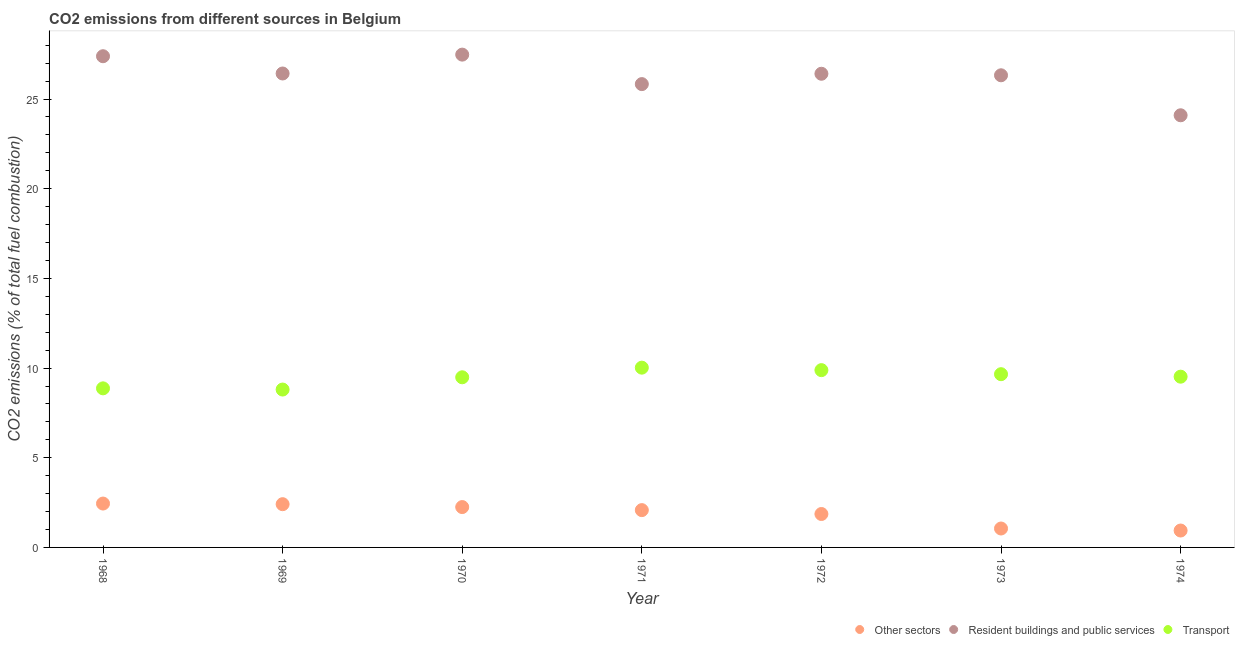How many different coloured dotlines are there?
Ensure brevity in your answer.  3. What is the percentage of co2 emissions from transport in 1973?
Give a very brief answer. 9.66. Across all years, what is the maximum percentage of co2 emissions from transport?
Your answer should be compact. 10.02. Across all years, what is the minimum percentage of co2 emissions from resident buildings and public services?
Give a very brief answer. 24.09. In which year was the percentage of co2 emissions from other sectors minimum?
Offer a very short reply. 1974. What is the total percentage of co2 emissions from resident buildings and public services in the graph?
Make the answer very short. 183.95. What is the difference between the percentage of co2 emissions from other sectors in 1968 and that in 1971?
Provide a succinct answer. 0.37. What is the difference between the percentage of co2 emissions from other sectors in 1972 and the percentage of co2 emissions from resident buildings and public services in 1971?
Make the answer very short. -23.97. What is the average percentage of co2 emissions from transport per year?
Make the answer very short. 9.46. In the year 1968, what is the difference between the percentage of co2 emissions from transport and percentage of co2 emissions from resident buildings and public services?
Provide a succinct answer. -18.52. What is the ratio of the percentage of co2 emissions from transport in 1971 to that in 1973?
Ensure brevity in your answer.  1.04. Is the percentage of co2 emissions from transport in 1968 less than that in 1970?
Provide a short and direct response. Yes. What is the difference between the highest and the second highest percentage of co2 emissions from other sectors?
Provide a succinct answer. 0.04. What is the difference between the highest and the lowest percentage of co2 emissions from resident buildings and public services?
Your answer should be very brief. 3.38. Is it the case that in every year, the sum of the percentage of co2 emissions from other sectors and percentage of co2 emissions from resident buildings and public services is greater than the percentage of co2 emissions from transport?
Offer a terse response. Yes. Does the percentage of co2 emissions from resident buildings and public services monotonically increase over the years?
Offer a very short reply. No. Is the percentage of co2 emissions from resident buildings and public services strictly greater than the percentage of co2 emissions from transport over the years?
Provide a short and direct response. Yes. Is the percentage of co2 emissions from transport strictly less than the percentage of co2 emissions from other sectors over the years?
Make the answer very short. No. How many dotlines are there?
Give a very brief answer. 3. Are the values on the major ticks of Y-axis written in scientific E-notation?
Provide a succinct answer. No. Does the graph contain any zero values?
Give a very brief answer. No. Does the graph contain grids?
Provide a succinct answer. No. Where does the legend appear in the graph?
Your answer should be very brief. Bottom right. What is the title of the graph?
Ensure brevity in your answer.  CO2 emissions from different sources in Belgium. What is the label or title of the X-axis?
Your answer should be very brief. Year. What is the label or title of the Y-axis?
Keep it short and to the point. CO2 emissions (% of total fuel combustion). What is the CO2 emissions (% of total fuel combustion) in Other sectors in 1968?
Offer a very short reply. 2.45. What is the CO2 emissions (% of total fuel combustion) of Resident buildings and public services in 1968?
Keep it short and to the point. 27.39. What is the CO2 emissions (% of total fuel combustion) of Transport in 1968?
Ensure brevity in your answer.  8.87. What is the CO2 emissions (% of total fuel combustion) in Other sectors in 1969?
Make the answer very short. 2.41. What is the CO2 emissions (% of total fuel combustion) of Resident buildings and public services in 1969?
Your response must be concise. 26.42. What is the CO2 emissions (% of total fuel combustion) of Transport in 1969?
Offer a very short reply. 8.8. What is the CO2 emissions (% of total fuel combustion) in Other sectors in 1970?
Provide a succinct answer. 2.25. What is the CO2 emissions (% of total fuel combustion) of Resident buildings and public services in 1970?
Offer a very short reply. 27.48. What is the CO2 emissions (% of total fuel combustion) of Transport in 1970?
Make the answer very short. 9.49. What is the CO2 emissions (% of total fuel combustion) in Other sectors in 1971?
Your response must be concise. 2.08. What is the CO2 emissions (% of total fuel combustion) in Resident buildings and public services in 1971?
Provide a succinct answer. 25.83. What is the CO2 emissions (% of total fuel combustion) in Transport in 1971?
Your response must be concise. 10.02. What is the CO2 emissions (% of total fuel combustion) in Other sectors in 1972?
Your answer should be very brief. 1.86. What is the CO2 emissions (% of total fuel combustion) in Resident buildings and public services in 1972?
Your response must be concise. 26.41. What is the CO2 emissions (% of total fuel combustion) of Transport in 1972?
Provide a short and direct response. 9.88. What is the CO2 emissions (% of total fuel combustion) of Other sectors in 1973?
Offer a very short reply. 1.05. What is the CO2 emissions (% of total fuel combustion) of Resident buildings and public services in 1973?
Offer a very short reply. 26.32. What is the CO2 emissions (% of total fuel combustion) of Transport in 1973?
Offer a terse response. 9.66. What is the CO2 emissions (% of total fuel combustion) of Other sectors in 1974?
Provide a short and direct response. 0.94. What is the CO2 emissions (% of total fuel combustion) of Resident buildings and public services in 1974?
Offer a terse response. 24.09. What is the CO2 emissions (% of total fuel combustion) of Transport in 1974?
Your answer should be very brief. 9.52. Across all years, what is the maximum CO2 emissions (% of total fuel combustion) in Other sectors?
Your response must be concise. 2.45. Across all years, what is the maximum CO2 emissions (% of total fuel combustion) of Resident buildings and public services?
Your answer should be very brief. 27.48. Across all years, what is the maximum CO2 emissions (% of total fuel combustion) of Transport?
Provide a succinct answer. 10.02. Across all years, what is the minimum CO2 emissions (% of total fuel combustion) of Other sectors?
Provide a succinct answer. 0.94. Across all years, what is the minimum CO2 emissions (% of total fuel combustion) in Resident buildings and public services?
Your response must be concise. 24.09. Across all years, what is the minimum CO2 emissions (% of total fuel combustion) of Transport?
Provide a succinct answer. 8.8. What is the total CO2 emissions (% of total fuel combustion) in Other sectors in the graph?
Provide a succinct answer. 13.05. What is the total CO2 emissions (% of total fuel combustion) of Resident buildings and public services in the graph?
Your answer should be compact. 183.95. What is the total CO2 emissions (% of total fuel combustion) in Transport in the graph?
Make the answer very short. 66.24. What is the difference between the CO2 emissions (% of total fuel combustion) in Other sectors in 1968 and that in 1969?
Keep it short and to the point. 0.04. What is the difference between the CO2 emissions (% of total fuel combustion) in Resident buildings and public services in 1968 and that in 1969?
Give a very brief answer. 0.96. What is the difference between the CO2 emissions (% of total fuel combustion) of Transport in 1968 and that in 1969?
Your answer should be compact. 0.07. What is the difference between the CO2 emissions (% of total fuel combustion) of Other sectors in 1968 and that in 1970?
Keep it short and to the point. 0.2. What is the difference between the CO2 emissions (% of total fuel combustion) of Resident buildings and public services in 1968 and that in 1970?
Provide a succinct answer. -0.09. What is the difference between the CO2 emissions (% of total fuel combustion) of Transport in 1968 and that in 1970?
Offer a very short reply. -0.62. What is the difference between the CO2 emissions (% of total fuel combustion) of Other sectors in 1968 and that in 1971?
Provide a short and direct response. 0.37. What is the difference between the CO2 emissions (% of total fuel combustion) of Resident buildings and public services in 1968 and that in 1971?
Your answer should be very brief. 1.55. What is the difference between the CO2 emissions (% of total fuel combustion) of Transport in 1968 and that in 1971?
Offer a very short reply. -1.15. What is the difference between the CO2 emissions (% of total fuel combustion) in Other sectors in 1968 and that in 1972?
Keep it short and to the point. 0.58. What is the difference between the CO2 emissions (% of total fuel combustion) of Resident buildings and public services in 1968 and that in 1972?
Offer a terse response. 0.98. What is the difference between the CO2 emissions (% of total fuel combustion) of Transport in 1968 and that in 1972?
Keep it short and to the point. -1.02. What is the difference between the CO2 emissions (% of total fuel combustion) in Other sectors in 1968 and that in 1973?
Offer a very short reply. 1.39. What is the difference between the CO2 emissions (% of total fuel combustion) of Resident buildings and public services in 1968 and that in 1973?
Your response must be concise. 1.06. What is the difference between the CO2 emissions (% of total fuel combustion) of Transport in 1968 and that in 1973?
Your answer should be very brief. -0.79. What is the difference between the CO2 emissions (% of total fuel combustion) of Other sectors in 1968 and that in 1974?
Give a very brief answer. 1.5. What is the difference between the CO2 emissions (% of total fuel combustion) in Resident buildings and public services in 1968 and that in 1974?
Give a very brief answer. 3.29. What is the difference between the CO2 emissions (% of total fuel combustion) in Transport in 1968 and that in 1974?
Keep it short and to the point. -0.65. What is the difference between the CO2 emissions (% of total fuel combustion) of Other sectors in 1969 and that in 1970?
Give a very brief answer. 0.16. What is the difference between the CO2 emissions (% of total fuel combustion) in Resident buildings and public services in 1969 and that in 1970?
Keep it short and to the point. -1.05. What is the difference between the CO2 emissions (% of total fuel combustion) of Transport in 1969 and that in 1970?
Your answer should be very brief. -0.68. What is the difference between the CO2 emissions (% of total fuel combustion) in Other sectors in 1969 and that in 1971?
Provide a short and direct response. 0.33. What is the difference between the CO2 emissions (% of total fuel combustion) in Resident buildings and public services in 1969 and that in 1971?
Your answer should be compact. 0.59. What is the difference between the CO2 emissions (% of total fuel combustion) of Transport in 1969 and that in 1971?
Offer a terse response. -1.22. What is the difference between the CO2 emissions (% of total fuel combustion) in Other sectors in 1969 and that in 1972?
Ensure brevity in your answer.  0.55. What is the difference between the CO2 emissions (% of total fuel combustion) in Resident buildings and public services in 1969 and that in 1972?
Make the answer very short. 0.02. What is the difference between the CO2 emissions (% of total fuel combustion) of Transport in 1969 and that in 1972?
Your response must be concise. -1.08. What is the difference between the CO2 emissions (% of total fuel combustion) of Other sectors in 1969 and that in 1973?
Your answer should be very brief. 1.36. What is the difference between the CO2 emissions (% of total fuel combustion) in Resident buildings and public services in 1969 and that in 1973?
Your response must be concise. 0.1. What is the difference between the CO2 emissions (% of total fuel combustion) of Transport in 1969 and that in 1973?
Make the answer very short. -0.86. What is the difference between the CO2 emissions (% of total fuel combustion) of Other sectors in 1969 and that in 1974?
Provide a short and direct response. 1.47. What is the difference between the CO2 emissions (% of total fuel combustion) in Resident buildings and public services in 1969 and that in 1974?
Your answer should be compact. 2.33. What is the difference between the CO2 emissions (% of total fuel combustion) in Transport in 1969 and that in 1974?
Your answer should be compact. -0.72. What is the difference between the CO2 emissions (% of total fuel combustion) in Other sectors in 1970 and that in 1971?
Offer a terse response. 0.17. What is the difference between the CO2 emissions (% of total fuel combustion) of Resident buildings and public services in 1970 and that in 1971?
Make the answer very short. 1.64. What is the difference between the CO2 emissions (% of total fuel combustion) in Transport in 1970 and that in 1971?
Offer a very short reply. -0.54. What is the difference between the CO2 emissions (% of total fuel combustion) in Other sectors in 1970 and that in 1972?
Provide a short and direct response. 0.39. What is the difference between the CO2 emissions (% of total fuel combustion) of Resident buildings and public services in 1970 and that in 1972?
Make the answer very short. 1.07. What is the difference between the CO2 emissions (% of total fuel combustion) of Transport in 1970 and that in 1972?
Make the answer very short. -0.4. What is the difference between the CO2 emissions (% of total fuel combustion) of Other sectors in 1970 and that in 1973?
Your response must be concise. 1.2. What is the difference between the CO2 emissions (% of total fuel combustion) in Resident buildings and public services in 1970 and that in 1973?
Provide a short and direct response. 1.15. What is the difference between the CO2 emissions (% of total fuel combustion) in Transport in 1970 and that in 1973?
Your answer should be very brief. -0.17. What is the difference between the CO2 emissions (% of total fuel combustion) in Other sectors in 1970 and that in 1974?
Keep it short and to the point. 1.31. What is the difference between the CO2 emissions (% of total fuel combustion) of Resident buildings and public services in 1970 and that in 1974?
Keep it short and to the point. 3.38. What is the difference between the CO2 emissions (% of total fuel combustion) in Transport in 1970 and that in 1974?
Make the answer very short. -0.03. What is the difference between the CO2 emissions (% of total fuel combustion) of Other sectors in 1971 and that in 1972?
Offer a terse response. 0.22. What is the difference between the CO2 emissions (% of total fuel combustion) in Resident buildings and public services in 1971 and that in 1972?
Give a very brief answer. -0.58. What is the difference between the CO2 emissions (% of total fuel combustion) in Transport in 1971 and that in 1972?
Offer a very short reply. 0.14. What is the difference between the CO2 emissions (% of total fuel combustion) in Other sectors in 1971 and that in 1973?
Your response must be concise. 1.03. What is the difference between the CO2 emissions (% of total fuel combustion) in Resident buildings and public services in 1971 and that in 1973?
Provide a short and direct response. -0.49. What is the difference between the CO2 emissions (% of total fuel combustion) in Transport in 1971 and that in 1973?
Your answer should be compact. 0.36. What is the difference between the CO2 emissions (% of total fuel combustion) of Other sectors in 1971 and that in 1974?
Provide a succinct answer. 1.14. What is the difference between the CO2 emissions (% of total fuel combustion) in Resident buildings and public services in 1971 and that in 1974?
Make the answer very short. 1.74. What is the difference between the CO2 emissions (% of total fuel combustion) in Transport in 1971 and that in 1974?
Ensure brevity in your answer.  0.5. What is the difference between the CO2 emissions (% of total fuel combustion) in Other sectors in 1972 and that in 1973?
Your answer should be very brief. 0.81. What is the difference between the CO2 emissions (% of total fuel combustion) of Resident buildings and public services in 1972 and that in 1973?
Ensure brevity in your answer.  0.09. What is the difference between the CO2 emissions (% of total fuel combustion) of Transport in 1972 and that in 1973?
Your response must be concise. 0.23. What is the difference between the CO2 emissions (% of total fuel combustion) of Other sectors in 1972 and that in 1974?
Offer a terse response. 0.92. What is the difference between the CO2 emissions (% of total fuel combustion) of Resident buildings and public services in 1972 and that in 1974?
Ensure brevity in your answer.  2.31. What is the difference between the CO2 emissions (% of total fuel combustion) of Transport in 1972 and that in 1974?
Your response must be concise. 0.36. What is the difference between the CO2 emissions (% of total fuel combustion) in Other sectors in 1973 and that in 1974?
Give a very brief answer. 0.11. What is the difference between the CO2 emissions (% of total fuel combustion) of Resident buildings and public services in 1973 and that in 1974?
Your response must be concise. 2.23. What is the difference between the CO2 emissions (% of total fuel combustion) of Transport in 1973 and that in 1974?
Ensure brevity in your answer.  0.14. What is the difference between the CO2 emissions (% of total fuel combustion) of Other sectors in 1968 and the CO2 emissions (% of total fuel combustion) of Resident buildings and public services in 1969?
Give a very brief answer. -23.98. What is the difference between the CO2 emissions (% of total fuel combustion) of Other sectors in 1968 and the CO2 emissions (% of total fuel combustion) of Transport in 1969?
Offer a very short reply. -6.36. What is the difference between the CO2 emissions (% of total fuel combustion) in Resident buildings and public services in 1968 and the CO2 emissions (% of total fuel combustion) in Transport in 1969?
Keep it short and to the point. 18.58. What is the difference between the CO2 emissions (% of total fuel combustion) in Other sectors in 1968 and the CO2 emissions (% of total fuel combustion) in Resident buildings and public services in 1970?
Keep it short and to the point. -25.03. What is the difference between the CO2 emissions (% of total fuel combustion) in Other sectors in 1968 and the CO2 emissions (% of total fuel combustion) in Transport in 1970?
Keep it short and to the point. -7.04. What is the difference between the CO2 emissions (% of total fuel combustion) in Resident buildings and public services in 1968 and the CO2 emissions (% of total fuel combustion) in Transport in 1970?
Your response must be concise. 17.9. What is the difference between the CO2 emissions (% of total fuel combustion) of Other sectors in 1968 and the CO2 emissions (% of total fuel combustion) of Resident buildings and public services in 1971?
Give a very brief answer. -23.39. What is the difference between the CO2 emissions (% of total fuel combustion) in Other sectors in 1968 and the CO2 emissions (% of total fuel combustion) in Transport in 1971?
Your response must be concise. -7.58. What is the difference between the CO2 emissions (% of total fuel combustion) of Resident buildings and public services in 1968 and the CO2 emissions (% of total fuel combustion) of Transport in 1971?
Your answer should be compact. 17.36. What is the difference between the CO2 emissions (% of total fuel combustion) in Other sectors in 1968 and the CO2 emissions (% of total fuel combustion) in Resident buildings and public services in 1972?
Your answer should be compact. -23.96. What is the difference between the CO2 emissions (% of total fuel combustion) of Other sectors in 1968 and the CO2 emissions (% of total fuel combustion) of Transport in 1972?
Give a very brief answer. -7.44. What is the difference between the CO2 emissions (% of total fuel combustion) of Resident buildings and public services in 1968 and the CO2 emissions (% of total fuel combustion) of Transport in 1972?
Make the answer very short. 17.5. What is the difference between the CO2 emissions (% of total fuel combustion) in Other sectors in 1968 and the CO2 emissions (% of total fuel combustion) in Resident buildings and public services in 1973?
Provide a succinct answer. -23.88. What is the difference between the CO2 emissions (% of total fuel combustion) of Other sectors in 1968 and the CO2 emissions (% of total fuel combustion) of Transport in 1973?
Your answer should be very brief. -7.21. What is the difference between the CO2 emissions (% of total fuel combustion) of Resident buildings and public services in 1968 and the CO2 emissions (% of total fuel combustion) of Transport in 1973?
Your answer should be compact. 17.73. What is the difference between the CO2 emissions (% of total fuel combustion) of Other sectors in 1968 and the CO2 emissions (% of total fuel combustion) of Resident buildings and public services in 1974?
Your answer should be compact. -21.65. What is the difference between the CO2 emissions (% of total fuel combustion) of Other sectors in 1968 and the CO2 emissions (% of total fuel combustion) of Transport in 1974?
Keep it short and to the point. -7.07. What is the difference between the CO2 emissions (% of total fuel combustion) of Resident buildings and public services in 1968 and the CO2 emissions (% of total fuel combustion) of Transport in 1974?
Offer a terse response. 17.87. What is the difference between the CO2 emissions (% of total fuel combustion) in Other sectors in 1969 and the CO2 emissions (% of total fuel combustion) in Resident buildings and public services in 1970?
Provide a short and direct response. -25.07. What is the difference between the CO2 emissions (% of total fuel combustion) in Other sectors in 1969 and the CO2 emissions (% of total fuel combustion) in Transport in 1970?
Your answer should be compact. -7.08. What is the difference between the CO2 emissions (% of total fuel combustion) in Resident buildings and public services in 1969 and the CO2 emissions (% of total fuel combustion) in Transport in 1970?
Offer a very short reply. 16.94. What is the difference between the CO2 emissions (% of total fuel combustion) of Other sectors in 1969 and the CO2 emissions (% of total fuel combustion) of Resident buildings and public services in 1971?
Your response must be concise. -23.42. What is the difference between the CO2 emissions (% of total fuel combustion) in Other sectors in 1969 and the CO2 emissions (% of total fuel combustion) in Transport in 1971?
Offer a very short reply. -7.61. What is the difference between the CO2 emissions (% of total fuel combustion) of Resident buildings and public services in 1969 and the CO2 emissions (% of total fuel combustion) of Transport in 1971?
Make the answer very short. 16.4. What is the difference between the CO2 emissions (% of total fuel combustion) in Other sectors in 1969 and the CO2 emissions (% of total fuel combustion) in Resident buildings and public services in 1972?
Provide a short and direct response. -24. What is the difference between the CO2 emissions (% of total fuel combustion) in Other sectors in 1969 and the CO2 emissions (% of total fuel combustion) in Transport in 1972?
Your response must be concise. -7.47. What is the difference between the CO2 emissions (% of total fuel combustion) in Resident buildings and public services in 1969 and the CO2 emissions (% of total fuel combustion) in Transport in 1972?
Offer a terse response. 16.54. What is the difference between the CO2 emissions (% of total fuel combustion) of Other sectors in 1969 and the CO2 emissions (% of total fuel combustion) of Resident buildings and public services in 1973?
Offer a terse response. -23.91. What is the difference between the CO2 emissions (% of total fuel combustion) in Other sectors in 1969 and the CO2 emissions (% of total fuel combustion) in Transport in 1973?
Offer a very short reply. -7.25. What is the difference between the CO2 emissions (% of total fuel combustion) in Resident buildings and public services in 1969 and the CO2 emissions (% of total fuel combustion) in Transport in 1973?
Your answer should be compact. 16.77. What is the difference between the CO2 emissions (% of total fuel combustion) of Other sectors in 1969 and the CO2 emissions (% of total fuel combustion) of Resident buildings and public services in 1974?
Offer a terse response. -21.68. What is the difference between the CO2 emissions (% of total fuel combustion) of Other sectors in 1969 and the CO2 emissions (% of total fuel combustion) of Transport in 1974?
Make the answer very short. -7.11. What is the difference between the CO2 emissions (% of total fuel combustion) in Resident buildings and public services in 1969 and the CO2 emissions (% of total fuel combustion) in Transport in 1974?
Offer a very short reply. 16.9. What is the difference between the CO2 emissions (% of total fuel combustion) of Other sectors in 1970 and the CO2 emissions (% of total fuel combustion) of Resident buildings and public services in 1971?
Provide a succinct answer. -23.58. What is the difference between the CO2 emissions (% of total fuel combustion) in Other sectors in 1970 and the CO2 emissions (% of total fuel combustion) in Transport in 1971?
Your answer should be compact. -7.77. What is the difference between the CO2 emissions (% of total fuel combustion) of Resident buildings and public services in 1970 and the CO2 emissions (% of total fuel combustion) of Transport in 1971?
Provide a short and direct response. 17.45. What is the difference between the CO2 emissions (% of total fuel combustion) of Other sectors in 1970 and the CO2 emissions (% of total fuel combustion) of Resident buildings and public services in 1972?
Provide a succinct answer. -24.16. What is the difference between the CO2 emissions (% of total fuel combustion) in Other sectors in 1970 and the CO2 emissions (% of total fuel combustion) in Transport in 1972?
Give a very brief answer. -7.63. What is the difference between the CO2 emissions (% of total fuel combustion) of Resident buildings and public services in 1970 and the CO2 emissions (% of total fuel combustion) of Transport in 1972?
Provide a succinct answer. 17.59. What is the difference between the CO2 emissions (% of total fuel combustion) of Other sectors in 1970 and the CO2 emissions (% of total fuel combustion) of Resident buildings and public services in 1973?
Your answer should be very brief. -24.07. What is the difference between the CO2 emissions (% of total fuel combustion) in Other sectors in 1970 and the CO2 emissions (% of total fuel combustion) in Transport in 1973?
Provide a succinct answer. -7.41. What is the difference between the CO2 emissions (% of total fuel combustion) in Resident buildings and public services in 1970 and the CO2 emissions (% of total fuel combustion) in Transport in 1973?
Offer a terse response. 17.82. What is the difference between the CO2 emissions (% of total fuel combustion) of Other sectors in 1970 and the CO2 emissions (% of total fuel combustion) of Resident buildings and public services in 1974?
Your response must be concise. -21.84. What is the difference between the CO2 emissions (% of total fuel combustion) in Other sectors in 1970 and the CO2 emissions (% of total fuel combustion) in Transport in 1974?
Your answer should be compact. -7.27. What is the difference between the CO2 emissions (% of total fuel combustion) of Resident buildings and public services in 1970 and the CO2 emissions (% of total fuel combustion) of Transport in 1974?
Your answer should be compact. 17.96. What is the difference between the CO2 emissions (% of total fuel combustion) in Other sectors in 1971 and the CO2 emissions (% of total fuel combustion) in Resident buildings and public services in 1972?
Ensure brevity in your answer.  -24.33. What is the difference between the CO2 emissions (% of total fuel combustion) of Other sectors in 1971 and the CO2 emissions (% of total fuel combustion) of Transport in 1972?
Your answer should be compact. -7.8. What is the difference between the CO2 emissions (% of total fuel combustion) of Resident buildings and public services in 1971 and the CO2 emissions (% of total fuel combustion) of Transport in 1972?
Ensure brevity in your answer.  15.95. What is the difference between the CO2 emissions (% of total fuel combustion) in Other sectors in 1971 and the CO2 emissions (% of total fuel combustion) in Resident buildings and public services in 1973?
Ensure brevity in your answer.  -24.24. What is the difference between the CO2 emissions (% of total fuel combustion) of Other sectors in 1971 and the CO2 emissions (% of total fuel combustion) of Transport in 1973?
Provide a short and direct response. -7.58. What is the difference between the CO2 emissions (% of total fuel combustion) in Resident buildings and public services in 1971 and the CO2 emissions (% of total fuel combustion) in Transport in 1973?
Your response must be concise. 16.17. What is the difference between the CO2 emissions (% of total fuel combustion) in Other sectors in 1971 and the CO2 emissions (% of total fuel combustion) in Resident buildings and public services in 1974?
Ensure brevity in your answer.  -22.01. What is the difference between the CO2 emissions (% of total fuel combustion) in Other sectors in 1971 and the CO2 emissions (% of total fuel combustion) in Transport in 1974?
Give a very brief answer. -7.44. What is the difference between the CO2 emissions (% of total fuel combustion) of Resident buildings and public services in 1971 and the CO2 emissions (% of total fuel combustion) of Transport in 1974?
Make the answer very short. 16.31. What is the difference between the CO2 emissions (% of total fuel combustion) of Other sectors in 1972 and the CO2 emissions (% of total fuel combustion) of Resident buildings and public services in 1973?
Your response must be concise. -24.46. What is the difference between the CO2 emissions (% of total fuel combustion) in Other sectors in 1972 and the CO2 emissions (% of total fuel combustion) in Transport in 1973?
Offer a very short reply. -7.8. What is the difference between the CO2 emissions (% of total fuel combustion) in Resident buildings and public services in 1972 and the CO2 emissions (% of total fuel combustion) in Transport in 1973?
Ensure brevity in your answer.  16.75. What is the difference between the CO2 emissions (% of total fuel combustion) of Other sectors in 1972 and the CO2 emissions (% of total fuel combustion) of Resident buildings and public services in 1974?
Make the answer very short. -22.23. What is the difference between the CO2 emissions (% of total fuel combustion) of Other sectors in 1972 and the CO2 emissions (% of total fuel combustion) of Transport in 1974?
Your response must be concise. -7.66. What is the difference between the CO2 emissions (% of total fuel combustion) of Resident buildings and public services in 1972 and the CO2 emissions (% of total fuel combustion) of Transport in 1974?
Keep it short and to the point. 16.89. What is the difference between the CO2 emissions (% of total fuel combustion) of Other sectors in 1973 and the CO2 emissions (% of total fuel combustion) of Resident buildings and public services in 1974?
Provide a short and direct response. -23.04. What is the difference between the CO2 emissions (% of total fuel combustion) in Other sectors in 1973 and the CO2 emissions (% of total fuel combustion) in Transport in 1974?
Give a very brief answer. -8.46. What is the difference between the CO2 emissions (% of total fuel combustion) in Resident buildings and public services in 1973 and the CO2 emissions (% of total fuel combustion) in Transport in 1974?
Make the answer very short. 16.8. What is the average CO2 emissions (% of total fuel combustion) in Other sectors per year?
Give a very brief answer. 1.86. What is the average CO2 emissions (% of total fuel combustion) in Resident buildings and public services per year?
Offer a terse response. 26.28. What is the average CO2 emissions (% of total fuel combustion) in Transport per year?
Give a very brief answer. 9.46. In the year 1968, what is the difference between the CO2 emissions (% of total fuel combustion) in Other sectors and CO2 emissions (% of total fuel combustion) in Resident buildings and public services?
Give a very brief answer. -24.94. In the year 1968, what is the difference between the CO2 emissions (% of total fuel combustion) in Other sectors and CO2 emissions (% of total fuel combustion) in Transport?
Ensure brevity in your answer.  -6.42. In the year 1968, what is the difference between the CO2 emissions (% of total fuel combustion) of Resident buildings and public services and CO2 emissions (% of total fuel combustion) of Transport?
Your answer should be compact. 18.52. In the year 1969, what is the difference between the CO2 emissions (% of total fuel combustion) in Other sectors and CO2 emissions (% of total fuel combustion) in Resident buildings and public services?
Your answer should be very brief. -24.01. In the year 1969, what is the difference between the CO2 emissions (% of total fuel combustion) of Other sectors and CO2 emissions (% of total fuel combustion) of Transport?
Keep it short and to the point. -6.39. In the year 1969, what is the difference between the CO2 emissions (% of total fuel combustion) in Resident buildings and public services and CO2 emissions (% of total fuel combustion) in Transport?
Your answer should be compact. 17.62. In the year 1970, what is the difference between the CO2 emissions (% of total fuel combustion) in Other sectors and CO2 emissions (% of total fuel combustion) in Resident buildings and public services?
Your answer should be very brief. -25.23. In the year 1970, what is the difference between the CO2 emissions (% of total fuel combustion) in Other sectors and CO2 emissions (% of total fuel combustion) in Transport?
Make the answer very short. -7.24. In the year 1970, what is the difference between the CO2 emissions (% of total fuel combustion) of Resident buildings and public services and CO2 emissions (% of total fuel combustion) of Transport?
Keep it short and to the point. 17.99. In the year 1971, what is the difference between the CO2 emissions (% of total fuel combustion) of Other sectors and CO2 emissions (% of total fuel combustion) of Resident buildings and public services?
Your response must be concise. -23.75. In the year 1971, what is the difference between the CO2 emissions (% of total fuel combustion) of Other sectors and CO2 emissions (% of total fuel combustion) of Transport?
Your response must be concise. -7.94. In the year 1971, what is the difference between the CO2 emissions (% of total fuel combustion) of Resident buildings and public services and CO2 emissions (% of total fuel combustion) of Transport?
Make the answer very short. 15.81. In the year 1972, what is the difference between the CO2 emissions (% of total fuel combustion) in Other sectors and CO2 emissions (% of total fuel combustion) in Resident buildings and public services?
Ensure brevity in your answer.  -24.55. In the year 1972, what is the difference between the CO2 emissions (% of total fuel combustion) in Other sectors and CO2 emissions (% of total fuel combustion) in Transport?
Offer a terse response. -8.02. In the year 1972, what is the difference between the CO2 emissions (% of total fuel combustion) in Resident buildings and public services and CO2 emissions (% of total fuel combustion) in Transport?
Your response must be concise. 16.52. In the year 1973, what is the difference between the CO2 emissions (% of total fuel combustion) in Other sectors and CO2 emissions (% of total fuel combustion) in Resident buildings and public services?
Offer a very short reply. -25.27. In the year 1973, what is the difference between the CO2 emissions (% of total fuel combustion) of Other sectors and CO2 emissions (% of total fuel combustion) of Transport?
Your answer should be compact. -8.6. In the year 1973, what is the difference between the CO2 emissions (% of total fuel combustion) of Resident buildings and public services and CO2 emissions (% of total fuel combustion) of Transport?
Provide a short and direct response. 16.67. In the year 1974, what is the difference between the CO2 emissions (% of total fuel combustion) of Other sectors and CO2 emissions (% of total fuel combustion) of Resident buildings and public services?
Your response must be concise. -23.15. In the year 1974, what is the difference between the CO2 emissions (% of total fuel combustion) in Other sectors and CO2 emissions (% of total fuel combustion) in Transport?
Give a very brief answer. -8.58. In the year 1974, what is the difference between the CO2 emissions (% of total fuel combustion) of Resident buildings and public services and CO2 emissions (% of total fuel combustion) of Transport?
Provide a short and direct response. 14.57. What is the ratio of the CO2 emissions (% of total fuel combustion) of Other sectors in 1968 to that in 1969?
Keep it short and to the point. 1.01. What is the ratio of the CO2 emissions (% of total fuel combustion) in Resident buildings and public services in 1968 to that in 1969?
Your answer should be compact. 1.04. What is the ratio of the CO2 emissions (% of total fuel combustion) in Transport in 1968 to that in 1969?
Keep it short and to the point. 1.01. What is the ratio of the CO2 emissions (% of total fuel combustion) in Other sectors in 1968 to that in 1970?
Provide a short and direct response. 1.09. What is the ratio of the CO2 emissions (% of total fuel combustion) of Resident buildings and public services in 1968 to that in 1970?
Give a very brief answer. 1. What is the ratio of the CO2 emissions (% of total fuel combustion) in Transport in 1968 to that in 1970?
Your answer should be very brief. 0.94. What is the ratio of the CO2 emissions (% of total fuel combustion) of Other sectors in 1968 to that in 1971?
Keep it short and to the point. 1.18. What is the ratio of the CO2 emissions (% of total fuel combustion) in Resident buildings and public services in 1968 to that in 1971?
Provide a short and direct response. 1.06. What is the ratio of the CO2 emissions (% of total fuel combustion) in Transport in 1968 to that in 1971?
Your response must be concise. 0.88. What is the ratio of the CO2 emissions (% of total fuel combustion) of Other sectors in 1968 to that in 1972?
Keep it short and to the point. 1.31. What is the ratio of the CO2 emissions (% of total fuel combustion) of Transport in 1968 to that in 1972?
Provide a short and direct response. 0.9. What is the ratio of the CO2 emissions (% of total fuel combustion) of Other sectors in 1968 to that in 1973?
Ensure brevity in your answer.  2.32. What is the ratio of the CO2 emissions (% of total fuel combustion) in Resident buildings and public services in 1968 to that in 1973?
Make the answer very short. 1.04. What is the ratio of the CO2 emissions (% of total fuel combustion) in Transport in 1968 to that in 1973?
Keep it short and to the point. 0.92. What is the ratio of the CO2 emissions (% of total fuel combustion) of Other sectors in 1968 to that in 1974?
Your response must be concise. 2.6. What is the ratio of the CO2 emissions (% of total fuel combustion) of Resident buildings and public services in 1968 to that in 1974?
Give a very brief answer. 1.14. What is the ratio of the CO2 emissions (% of total fuel combustion) of Transport in 1968 to that in 1974?
Your answer should be compact. 0.93. What is the ratio of the CO2 emissions (% of total fuel combustion) of Other sectors in 1969 to that in 1970?
Your answer should be very brief. 1.07. What is the ratio of the CO2 emissions (% of total fuel combustion) of Resident buildings and public services in 1969 to that in 1970?
Offer a terse response. 0.96. What is the ratio of the CO2 emissions (% of total fuel combustion) of Transport in 1969 to that in 1970?
Offer a terse response. 0.93. What is the ratio of the CO2 emissions (% of total fuel combustion) in Other sectors in 1969 to that in 1971?
Offer a very short reply. 1.16. What is the ratio of the CO2 emissions (% of total fuel combustion) of Resident buildings and public services in 1969 to that in 1971?
Your response must be concise. 1.02. What is the ratio of the CO2 emissions (% of total fuel combustion) of Transport in 1969 to that in 1971?
Offer a terse response. 0.88. What is the ratio of the CO2 emissions (% of total fuel combustion) in Other sectors in 1969 to that in 1972?
Keep it short and to the point. 1.29. What is the ratio of the CO2 emissions (% of total fuel combustion) in Transport in 1969 to that in 1972?
Your answer should be very brief. 0.89. What is the ratio of the CO2 emissions (% of total fuel combustion) in Other sectors in 1969 to that in 1973?
Offer a very short reply. 2.29. What is the ratio of the CO2 emissions (% of total fuel combustion) in Transport in 1969 to that in 1973?
Ensure brevity in your answer.  0.91. What is the ratio of the CO2 emissions (% of total fuel combustion) of Other sectors in 1969 to that in 1974?
Your answer should be very brief. 2.56. What is the ratio of the CO2 emissions (% of total fuel combustion) in Resident buildings and public services in 1969 to that in 1974?
Provide a short and direct response. 1.1. What is the ratio of the CO2 emissions (% of total fuel combustion) of Transport in 1969 to that in 1974?
Your answer should be compact. 0.92. What is the ratio of the CO2 emissions (% of total fuel combustion) of Other sectors in 1970 to that in 1971?
Your response must be concise. 1.08. What is the ratio of the CO2 emissions (% of total fuel combustion) in Resident buildings and public services in 1970 to that in 1971?
Keep it short and to the point. 1.06. What is the ratio of the CO2 emissions (% of total fuel combustion) in Transport in 1970 to that in 1971?
Ensure brevity in your answer.  0.95. What is the ratio of the CO2 emissions (% of total fuel combustion) of Other sectors in 1970 to that in 1972?
Your answer should be compact. 1.21. What is the ratio of the CO2 emissions (% of total fuel combustion) in Resident buildings and public services in 1970 to that in 1972?
Offer a very short reply. 1.04. What is the ratio of the CO2 emissions (% of total fuel combustion) of Transport in 1970 to that in 1972?
Provide a short and direct response. 0.96. What is the ratio of the CO2 emissions (% of total fuel combustion) of Other sectors in 1970 to that in 1973?
Your response must be concise. 2.13. What is the ratio of the CO2 emissions (% of total fuel combustion) of Resident buildings and public services in 1970 to that in 1973?
Keep it short and to the point. 1.04. What is the ratio of the CO2 emissions (% of total fuel combustion) in Transport in 1970 to that in 1973?
Give a very brief answer. 0.98. What is the ratio of the CO2 emissions (% of total fuel combustion) in Other sectors in 1970 to that in 1974?
Offer a very short reply. 2.39. What is the ratio of the CO2 emissions (% of total fuel combustion) of Resident buildings and public services in 1970 to that in 1974?
Provide a short and direct response. 1.14. What is the ratio of the CO2 emissions (% of total fuel combustion) of Other sectors in 1971 to that in 1972?
Your answer should be very brief. 1.12. What is the ratio of the CO2 emissions (% of total fuel combustion) in Resident buildings and public services in 1971 to that in 1972?
Provide a short and direct response. 0.98. What is the ratio of the CO2 emissions (% of total fuel combustion) in Transport in 1971 to that in 1972?
Your response must be concise. 1.01. What is the ratio of the CO2 emissions (% of total fuel combustion) in Other sectors in 1971 to that in 1973?
Your response must be concise. 1.97. What is the ratio of the CO2 emissions (% of total fuel combustion) in Resident buildings and public services in 1971 to that in 1973?
Make the answer very short. 0.98. What is the ratio of the CO2 emissions (% of total fuel combustion) of Transport in 1971 to that in 1973?
Offer a terse response. 1.04. What is the ratio of the CO2 emissions (% of total fuel combustion) of Other sectors in 1971 to that in 1974?
Keep it short and to the point. 2.21. What is the ratio of the CO2 emissions (% of total fuel combustion) in Resident buildings and public services in 1971 to that in 1974?
Provide a succinct answer. 1.07. What is the ratio of the CO2 emissions (% of total fuel combustion) in Transport in 1971 to that in 1974?
Your response must be concise. 1.05. What is the ratio of the CO2 emissions (% of total fuel combustion) of Other sectors in 1972 to that in 1973?
Offer a very short reply. 1.77. What is the ratio of the CO2 emissions (% of total fuel combustion) in Resident buildings and public services in 1972 to that in 1973?
Make the answer very short. 1. What is the ratio of the CO2 emissions (% of total fuel combustion) in Transport in 1972 to that in 1973?
Offer a very short reply. 1.02. What is the ratio of the CO2 emissions (% of total fuel combustion) of Other sectors in 1972 to that in 1974?
Provide a short and direct response. 1.98. What is the ratio of the CO2 emissions (% of total fuel combustion) of Resident buildings and public services in 1972 to that in 1974?
Offer a terse response. 1.1. What is the ratio of the CO2 emissions (% of total fuel combustion) of Transport in 1972 to that in 1974?
Offer a very short reply. 1.04. What is the ratio of the CO2 emissions (% of total fuel combustion) in Other sectors in 1973 to that in 1974?
Offer a very short reply. 1.12. What is the ratio of the CO2 emissions (% of total fuel combustion) of Resident buildings and public services in 1973 to that in 1974?
Make the answer very short. 1.09. What is the ratio of the CO2 emissions (% of total fuel combustion) of Transport in 1973 to that in 1974?
Give a very brief answer. 1.01. What is the difference between the highest and the second highest CO2 emissions (% of total fuel combustion) of Other sectors?
Ensure brevity in your answer.  0.04. What is the difference between the highest and the second highest CO2 emissions (% of total fuel combustion) of Resident buildings and public services?
Your answer should be compact. 0.09. What is the difference between the highest and the second highest CO2 emissions (% of total fuel combustion) in Transport?
Offer a very short reply. 0.14. What is the difference between the highest and the lowest CO2 emissions (% of total fuel combustion) in Other sectors?
Offer a very short reply. 1.5. What is the difference between the highest and the lowest CO2 emissions (% of total fuel combustion) in Resident buildings and public services?
Make the answer very short. 3.38. What is the difference between the highest and the lowest CO2 emissions (% of total fuel combustion) in Transport?
Offer a terse response. 1.22. 